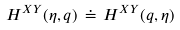Convert formula to latex. <formula><loc_0><loc_0><loc_500><loc_500>H ^ { X Y } ( \eta , q ) \, \doteq \, H ^ { X Y } ( q , \eta ) \,</formula> 